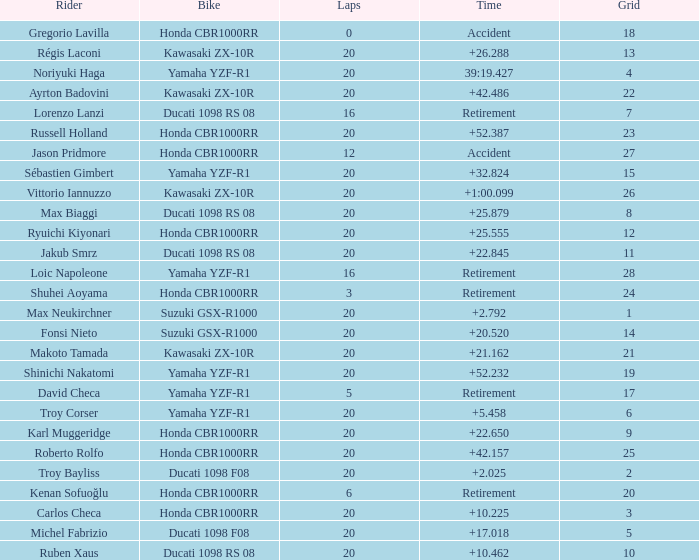What is the time of Troy Bayliss with less than 8 grids? 2.025. Can you give me this table as a dict? {'header': ['Rider', 'Bike', 'Laps', 'Time', 'Grid'], 'rows': [['Gregorio Lavilla', 'Honda CBR1000RR', '0', 'Accident', '18'], ['Régis Laconi', 'Kawasaki ZX-10R', '20', '+26.288', '13'], ['Noriyuki Haga', 'Yamaha YZF-R1', '20', '39:19.427', '4'], ['Ayrton Badovini', 'Kawasaki ZX-10R', '20', '+42.486', '22'], ['Lorenzo Lanzi', 'Ducati 1098 RS 08', '16', 'Retirement', '7'], ['Russell Holland', 'Honda CBR1000RR', '20', '+52.387', '23'], ['Jason Pridmore', 'Honda CBR1000RR', '12', 'Accident', '27'], ['Sébastien Gimbert', 'Yamaha YZF-R1', '20', '+32.824', '15'], ['Vittorio Iannuzzo', 'Kawasaki ZX-10R', '20', '+1:00.099', '26'], ['Max Biaggi', 'Ducati 1098 RS 08', '20', '+25.879', '8'], ['Ryuichi Kiyonari', 'Honda CBR1000RR', '20', '+25.555', '12'], ['Jakub Smrz', 'Ducati 1098 RS 08', '20', '+22.845', '11'], ['Loic Napoleone', 'Yamaha YZF-R1', '16', 'Retirement', '28'], ['Shuhei Aoyama', 'Honda CBR1000RR', '3', 'Retirement', '24'], ['Max Neukirchner', 'Suzuki GSX-R1000', '20', '+2.792', '1'], ['Fonsi Nieto', 'Suzuki GSX-R1000', '20', '+20.520', '14'], ['Makoto Tamada', 'Kawasaki ZX-10R', '20', '+21.162', '21'], ['Shinichi Nakatomi', 'Yamaha YZF-R1', '20', '+52.232', '19'], ['David Checa', 'Yamaha YZF-R1', '5', 'Retirement', '17'], ['Troy Corser', 'Yamaha YZF-R1', '20', '+5.458', '6'], ['Karl Muggeridge', 'Honda CBR1000RR', '20', '+22.650', '9'], ['Roberto Rolfo', 'Honda CBR1000RR', '20', '+42.157', '25'], ['Troy Bayliss', 'Ducati 1098 F08', '20', '+2.025', '2'], ['Kenan Sofuoğlu', 'Honda CBR1000RR', '6', 'Retirement', '20'], ['Carlos Checa', 'Honda CBR1000RR', '20', '+10.225', '3'], ['Michel Fabrizio', 'Ducati 1098 F08', '20', '+17.018', '5'], ['Ruben Xaus', 'Ducati 1098 RS 08', '20', '+10.462', '10']]} 